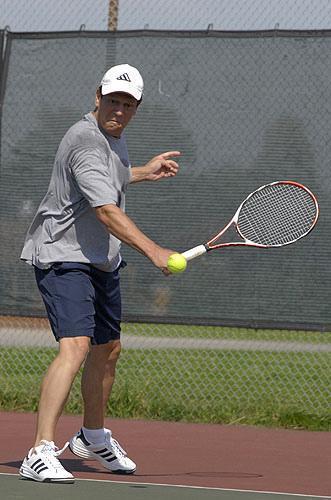How many tennis rackets are there?
Give a very brief answer. 1. 